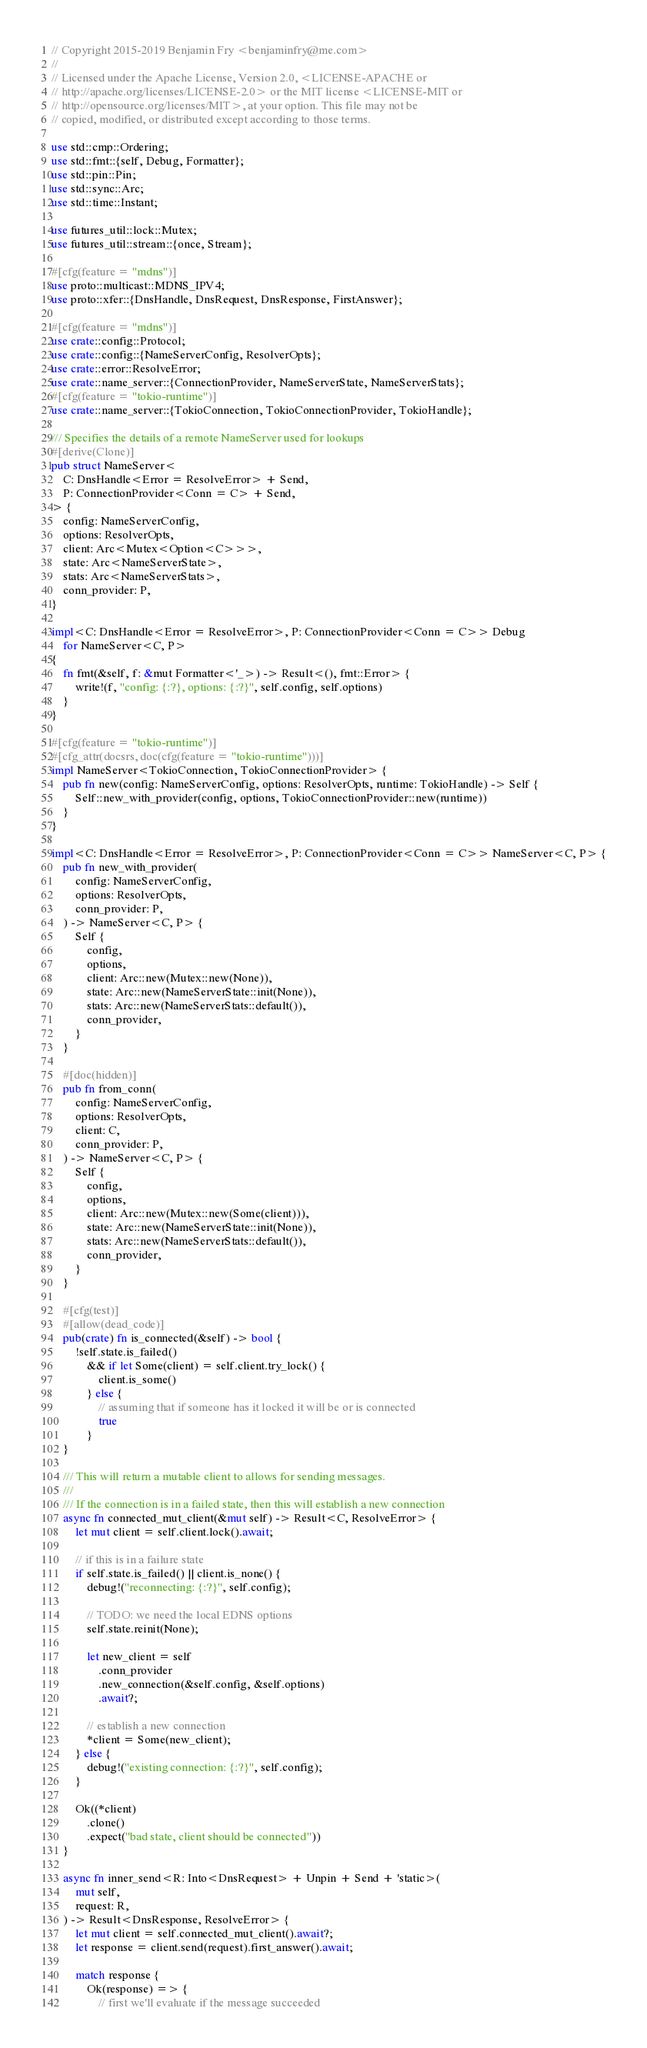<code> <loc_0><loc_0><loc_500><loc_500><_Rust_>// Copyright 2015-2019 Benjamin Fry <benjaminfry@me.com>
//
// Licensed under the Apache License, Version 2.0, <LICENSE-APACHE or
// http://apache.org/licenses/LICENSE-2.0> or the MIT license <LICENSE-MIT or
// http://opensource.org/licenses/MIT>, at your option. This file may not be
// copied, modified, or distributed except according to those terms.

use std::cmp::Ordering;
use std::fmt::{self, Debug, Formatter};
use std::pin::Pin;
use std::sync::Arc;
use std::time::Instant;

use futures_util::lock::Mutex;
use futures_util::stream::{once, Stream};

#[cfg(feature = "mdns")]
use proto::multicast::MDNS_IPV4;
use proto::xfer::{DnsHandle, DnsRequest, DnsResponse, FirstAnswer};

#[cfg(feature = "mdns")]
use crate::config::Protocol;
use crate::config::{NameServerConfig, ResolverOpts};
use crate::error::ResolveError;
use crate::name_server::{ConnectionProvider, NameServerState, NameServerStats};
#[cfg(feature = "tokio-runtime")]
use crate::name_server::{TokioConnection, TokioConnectionProvider, TokioHandle};

/// Specifies the details of a remote NameServer used for lookups
#[derive(Clone)]
pub struct NameServer<
    C: DnsHandle<Error = ResolveError> + Send,
    P: ConnectionProvider<Conn = C> + Send,
> {
    config: NameServerConfig,
    options: ResolverOpts,
    client: Arc<Mutex<Option<C>>>,
    state: Arc<NameServerState>,
    stats: Arc<NameServerStats>,
    conn_provider: P,
}

impl<C: DnsHandle<Error = ResolveError>, P: ConnectionProvider<Conn = C>> Debug
    for NameServer<C, P>
{
    fn fmt(&self, f: &mut Formatter<'_>) -> Result<(), fmt::Error> {
        write!(f, "config: {:?}, options: {:?}", self.config, self.options)
    }
}

#[cfg(feature = "tokio-runtime")]
#[cfg_attr(docsrs, doc(cfg(feature = "tokio-runtime")))]
impl NameServer<TokioConnection, TokioConnectionProvider> {
    pub fn new(config: NameServerConfig, options: ResolverOpts, runtime: TokioHandle) -> Self {
        Self::new_with_provider(config, options, TokioConnectionProvider::new(runtime))
    }
}

impl<C: DnsHandle<Error = ResolveError>, P: ConnectionProvider<Conn = C>> NameServer<C, P> {
    pub fn new_with_provider(
        config: NameServerConfig,
        options: ResolverOpts,
        conn_provider: P,
    ) -> NameServer<C, P> {
        Self {
            config,
            options,
            client: Arc::new(Mutex::new(None)),
            state: Arc::new(NameServerState::init(None)),
            stats: Arc::new(NameServerStats::default()),
            conn_provider,
        }
    }

    #[doc(hidden)]
    pub fn from_conn(
        config: NameServerConfig,
        options: ResolverOpts,
        client: C,
        conn_provider: P,
    ) -> NameServer<C, P> {
        Self {
            config,
            options,
            client: Arc::new(Mutex::new(Some(client))),
            state: Arc::new(NameServerState::init(None)),
            stats: Arc::new(NameServerStats::default()),
            conn_provider,
        }
    }

    #[cfg(test)]
    #[allow(dead_code)]
    pub(crate) fn is_connected(&self) -> bool {
        !self.state.is_failed()
            && if let Some(client) = self.client.try_lock() {
                client.is_some()
            } else {
                // assuming that if someone has it locked it will be or is connected
                true
            }
    }

    /// This will return a mutable client to allows for sending messages.
    ///
    /// If the connection is in a failed state, then this will establish a new connection
    async fn connected_mut_client(&mut self) -> Result<C, ResolveError> {
        let mut client = self.client.lock().await;

        // if this is in a failure state
        if self.state.is_failed() || client.is_none() {
            debug!("reconnecting: {:?}", self.config);

            // TODO: we need the local EDNS options
            self.state.reinit(None);

            let new_client = self
                .conn_provider
                .new_connection(&self.config, &self.options)
                .await?;

            // establish a new connection
            *client = Some(new_client);
        } else {
            debug!("existing connection: {:?}", self.config);
        }

        Ok((*client)
            .clone()
            .expect("bad state, client should be connected"))
    }

    async fn inner_send<R: Into<DnsRequest> + Unpin + Send + 'static>(
        mut self,
        request: R,
    ) -> Result<DnsResponse, ResolveError> {
        let mut client = self.connected_mut_client().await?;
        let response = client.send(request).first_answer().await;

        match response {
            Ok(response) => {
                // first we'll evaluate if the message succeeded</code> 